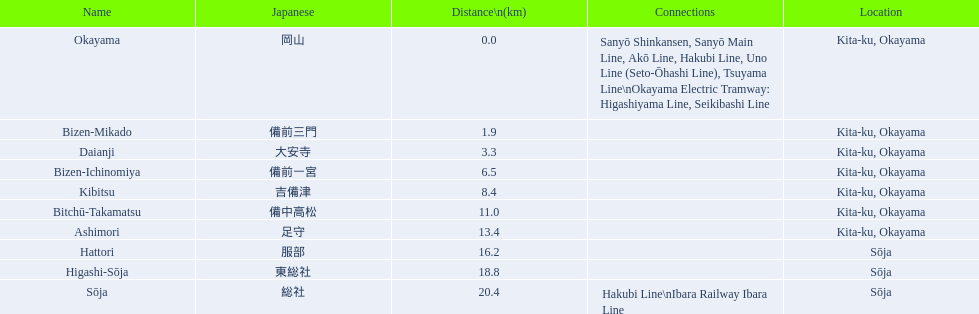What are all the stations on the kibi line? Okayama, Bizen-Mikado, Daianji, Bizen-Ichinomiya, Kibitsu, Bitchū-Takamatsu, Ashimori, Hattori, Higashi-Sōja, Sōja. What are the distances of these stations from the start of the line? 0.0, 1.9, 3.3, 6.5, 8.4, 11.0, 13.4, 16.2, 18.8, 20.4. Of these, which is larger than 1 km? 1.9, 3.3, 6.5, 8.4, 11.0, 13.4, 16.2, 18.8, 20.4. Of these, which is smaller than 2 km? 1.9. Which station is this distance from the start of the line? Bizen-Mikado. 